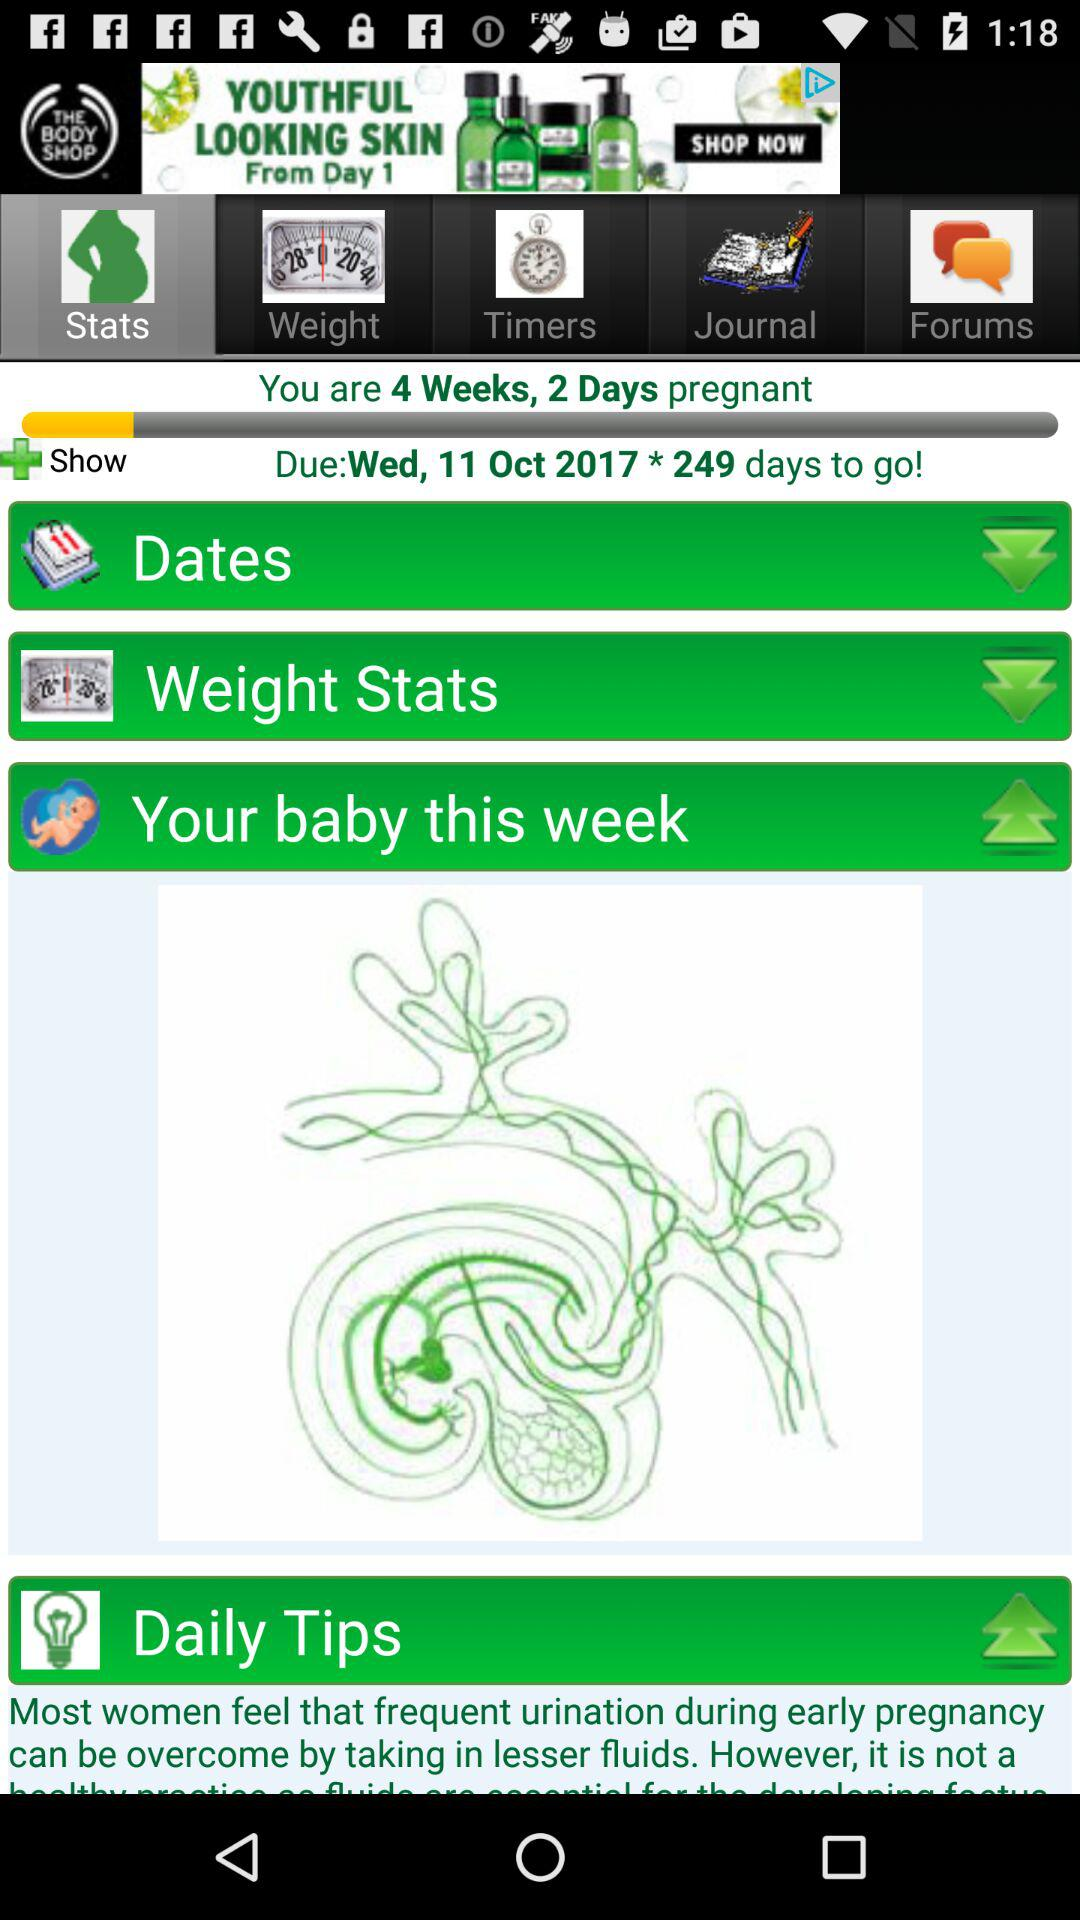How many weeks pregnant am I? You are 4 weeks pregnant. 